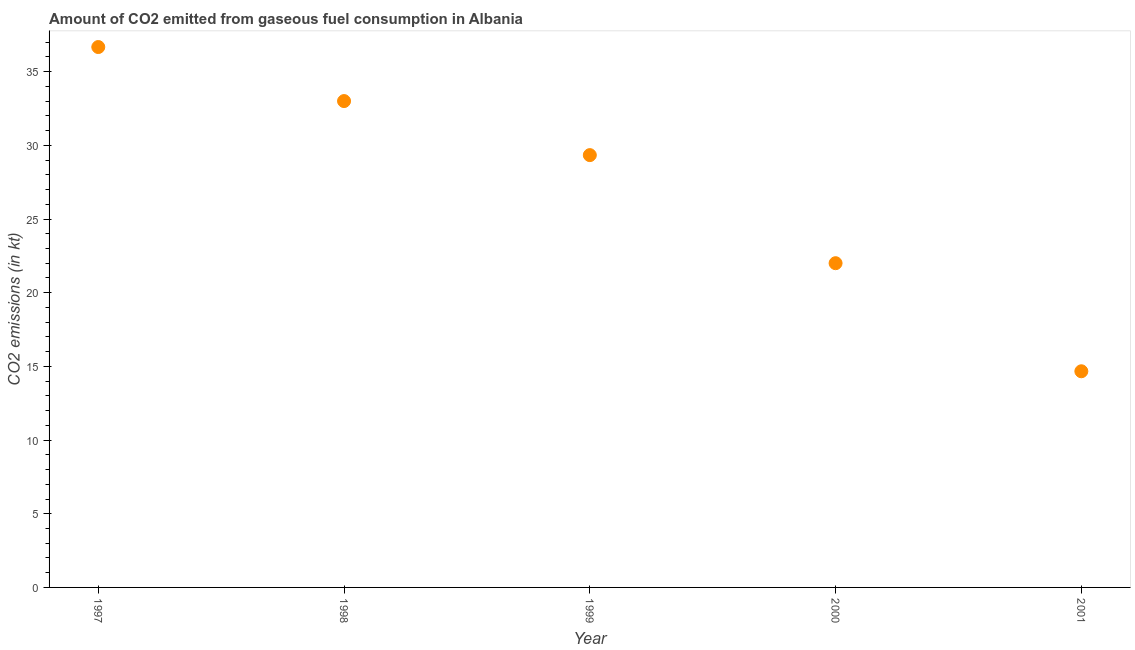What is the co2 emissions from gaseous fuel consumption in 1999?
Your answer should be compact. 29.34. Across all years, what is the maximum co2 emissions from gaseous fuel consumption?
Provide a succinct answer. 36.67. Across all years, what is the minimum co2 emissions from gaseous fuel consumption?
Offer a very short reply. 14.67. What is the sum of the co2 emissions from gaseous fuel consumption?
Provide a succinct answer. 135.68. What is the difference between the co2 emissions from gaseous fuel consumption in 2000 and 2001?
Provide a short and direct response. 7.33. What is the average co2 emissions from gaseous fuel consumption per year?
Provide a succinct answer. 27.14. What is the median co2 emissions from gaseous fuel consumption?
Provide a short and direct response. 29.34. In how many years, is the co2 emissions from gaseous fuel consumption greater than 28 kt?
Make the answer very short. 3. Do a majority of the years between 1999 and 1998 (inclusive) have co2 emissions from gaseous fuel consumption greater than 10 kt?
Provide a succinct answer. No. What is the ratio of the co2 emissions from gaseous fuel consumption in 1997 to that in 1998?
Your answer should be compact. 1.11. Is the difference between the co2 emissions from gaseous fuel consumption in 1998 and 2001 greater than the difference between any two years?
Provide a short and direct response. No. What is the difference between the highest and the second highest co2 emissions from gaseous fuel consumption?
Offer a very short reply. 3.67. What is the difference between the highest and the lowest co2 emissions from gaseous fuel consumption?
Provide a short and direct response. 22. How many dotlines are there?
Provide a succinct answer. 1. How many years are there in the graph?
Offer a terse response. 5. What is the difference between two consecutive major ticks on the Y-axis?
Your answer should be compact. 5. Are the values on the major ticks of Y-axis written in scientific E-notation?
Ensure brevity in your answer.  No. Does the graph contain any zero values?
Provide a succinct answer. No. What is the title of the graph?
Ensure brevity in your answer.  Amount of CO2 emitted from gaseous fuel consumption in Albania. What is the label or title of the Y-axis?
Provide a succinct answer. CO2 emissions (in kt). What is the CO2 emissions (in kt) in 1997?
Your answer should be very brief. 36.67. What is the CO2 emissions (in kt) in 1998?
Provide a succinct answer. 33. What is the CO2 emissions (in kt) in 1999?
Give a very brief answer. 29.34. What is the CO2 emissions (in kt) in 2000?
Offer a very short reply. 22. What is the CO2 emissions (in kt) in 2001?
Provide a succinct answer. 14.67. What is the difference between the CO2 emissions (in kt) in 1997 and 1998?
Make the answer very short. 3.67. What is the difference between the CO2 emissions (in kt) in 1997 and 1999?
Your answer should be compact. 7.33. What is the difference between the CO2 emissions (in kt) in 1997 and 2000?
Make the answer very short. 14.67. What is the difference between the CO2 emissions (in kt) in 1997 and 2001?
Your answer should be compact. 22. What is the difference between the CO2 emissions (in kt) in 1998 and 1999?
Ensure brevity in your answer.  3.67. What is the difference between the CO2 emissions (in kt) in 1998 and 2000?
Give a very brief answer. 11. What is the difference between the CO2 emissions (in kt) in 1998 and 2001?
Give a very brief answer. 18.34. What is the difference between the CO2 emissions (in kt) in 1999 and 2000?
Your response must be concise. 7.33. What is the difference between the CO2 emissions (in kt) in 1999 and 2001?
Ensure brevity in your answer.  14.67. What is the difference between the CO2 emissions (in kt) in 2000 and 2001?
Your answer should be compact. 7.33. What is the ratio of the CO2 emissions (in kt) in 1997 to that in 1998?
Give a very brief answer. 1.11. What is the ratio of the CO2 emissions (in kt) in 1997 to that in 2000?
Your response must be concise. 1.67. What is the ratio of the CO2 emissions (in kt) in 1997 to that in 2001?
Your answer should be compact. 2.5. What is the ratio of the CO2 emissions (in kt) in 1998 to that in 1999?
Your answer should be compact. 1.12. What is the ratio of the CO2 emissions (in kt) in 1998 to that in 2000?
Make the answer very short. 1.5. What is the ratio of the CO2 emissions (in kt) in 1998 to that in 2001?
Provide a succinct answer. 2.25. What is the ratio of the CO2 emissions (in kt) in 1999 to that in 2000?
Provide a succinct answer. 1.33. 